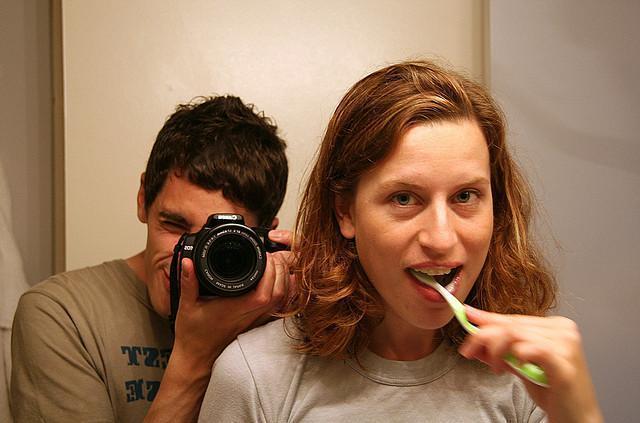How many people are visible?
Give a very brief answer. 2. How many white chairs are visible?
Give a very brief answer. 0. 